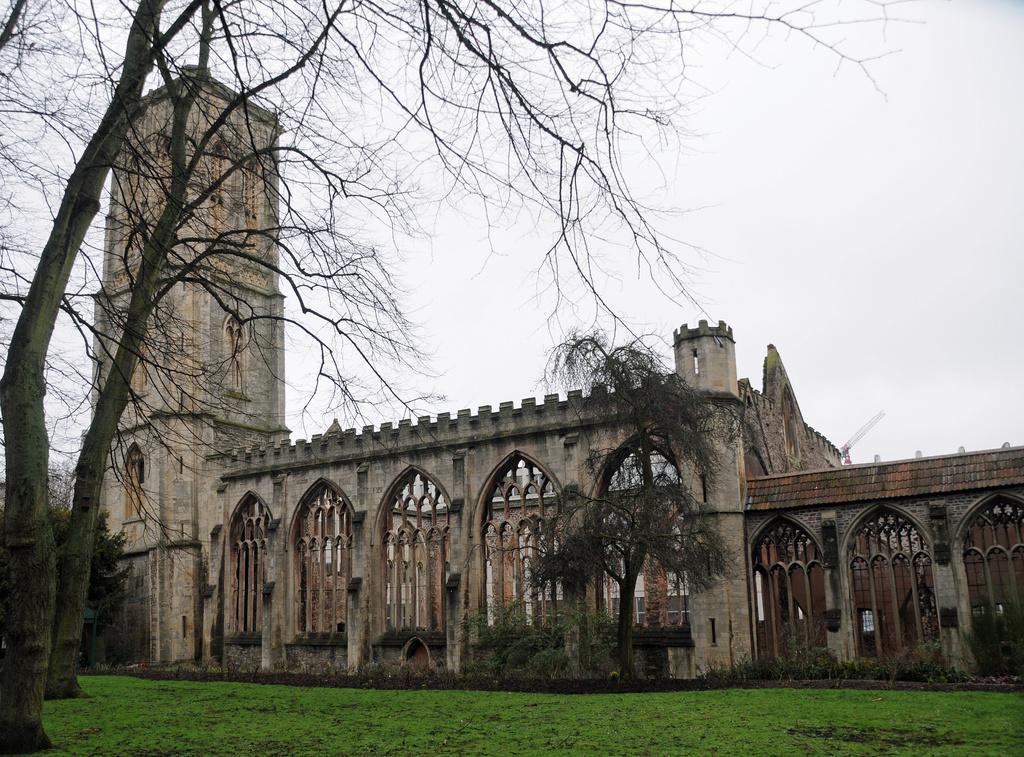In one or two sentences, can you explain what this image depicts? In this image in the front there's grass on the ground and there are trees. In the background is a tower and there are arch and the sky is cloudy and there are trees in the background. 